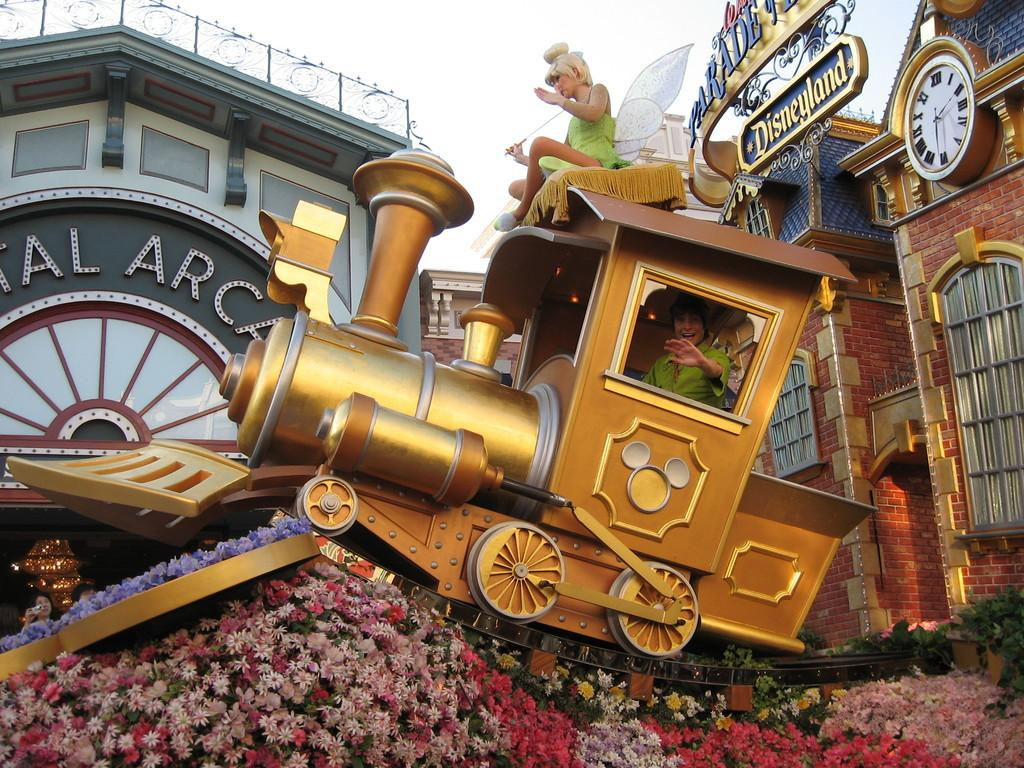<image>
Relay a brief, clear account of the picture shown. A child sits in a pretend train with a sign above him that says Disneyland. 